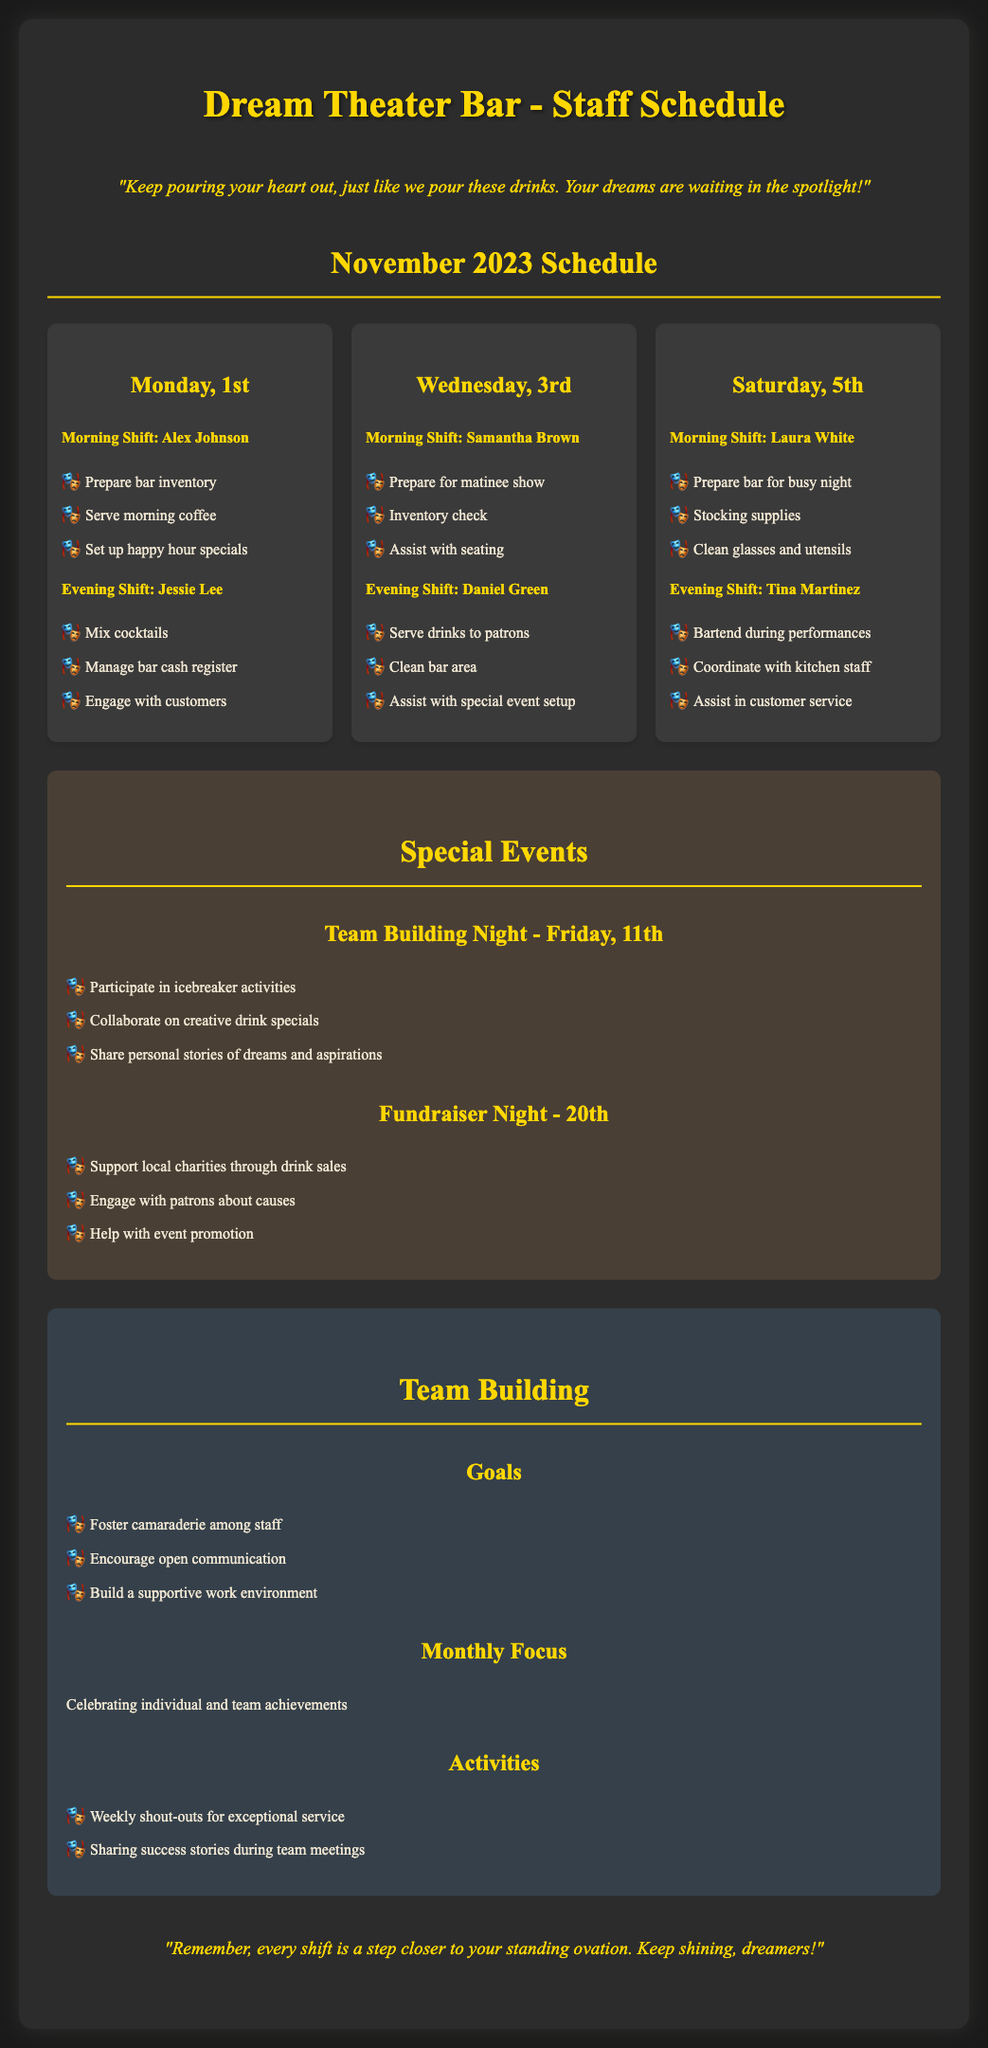what is the date of Team Building Night? Team Building Night is scheduled for Friday, 11th.
Answer: Friday, 11th who is the bartender for the evening shift on Monday, 1st? The bartender for the evening shift on Monday, 1st is Jessie Lee.
Answer: Jessie Lee what is one responsibility of Samantha Brown during her shift? One responsibility of Samantha Brown is to prepare for the matinee show.
Answer: Prepare for matinee show how many special events are listed in the document? The document lists two special events: Team Building Night and Fundraiser Night.
Answer: Two which shift is Laura White assigned to? Laura White is assigned to the morning shift on Saturday, 5th.
Answer: Morning Shift what is the focus of the monthly team building activities? The monthly focus is on celebrating individual and team achievements.
Answer: Celebrating individual and team achievements when is the Fundraiser Night scheduled? The Fundraiser Night is scheduled for the 20th.
Answer: 20th what type of activities will be included in the Team Building Night? The activities will include icebreaker activities and sharing personal stories.
Answer: Icebreaker activities 